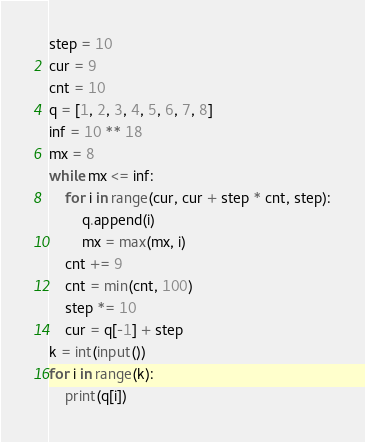<code> <loc_0><loc_0><loc_500><loc_500><_Python_>step = 10
cur = 9
cnt = 10
q = [1, 2, 3, 4, 5, 6, 7, 8]
inf = 10 ** 18
mx = 8
while mx <= inf:
    for i in range(cur, cur + step * cnt, step):
        q.append(i)
        mx = max(mx, i)
    cnt += 9
    cnt = min(cnt, 100)
    step *= 10
    cur = q[-1] + step
k = int(input())
for i in range(k):
    print(q[i])</code> 